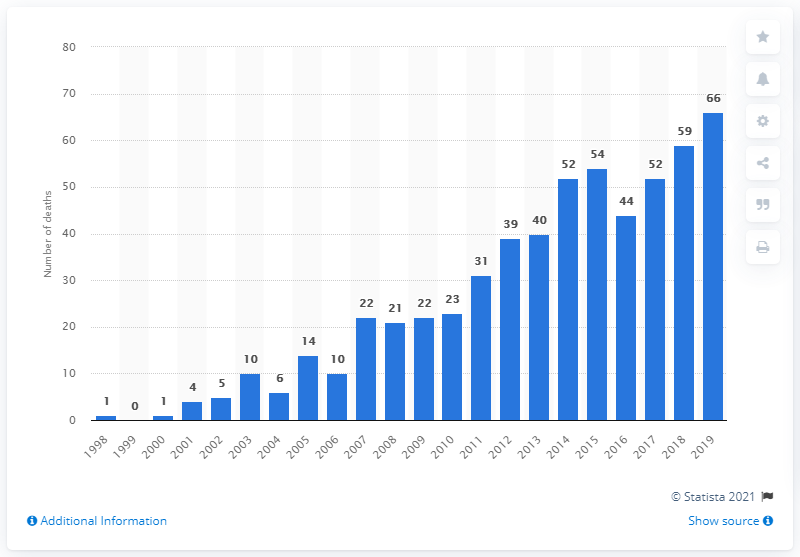List a handful of essential elements in this visual. In 2019, there were 66 reported deaths related to the use of quetiapine. 